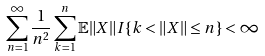<formula> <loc_0><loc_0><loc_500><loc_500>\sum _ { n = 1 } ^ { \infty } \frac { 1 } { n ^ { 2 } } \sum _ { k = 1 } ^ { n } \mathbb { E } \| X \| I \{ k < \| X \| \leq n \} < \infty</formula> 